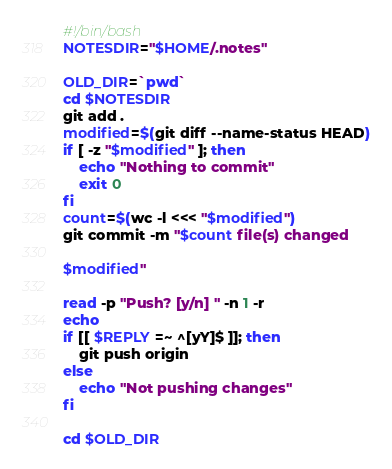<code> <loc_0><loc_0><loc_500><loc_500><_Bash_>#!/bin/bash
NOTESDIR="$HOME/.notes"

OLD_DIR=`pwd`
cd $NOTESDIR
git add .
modified=$(git diff --name-status HEAD)
if [ -z "$modified" ]; then
    echo "Nothing to commit"
    exit 0
fi
count=$(wc -l <<< "$modified")
git commit -m "$count file(s) changed

$modified"

read -p "Push? [y/n] " -n 1 -r
echo
if [[ $REPLY =~ ^[yY]$ ]]; then
    git push origin
else
    echo "Not pushing changes"
fi

cd $OLD_DIR
</code> 